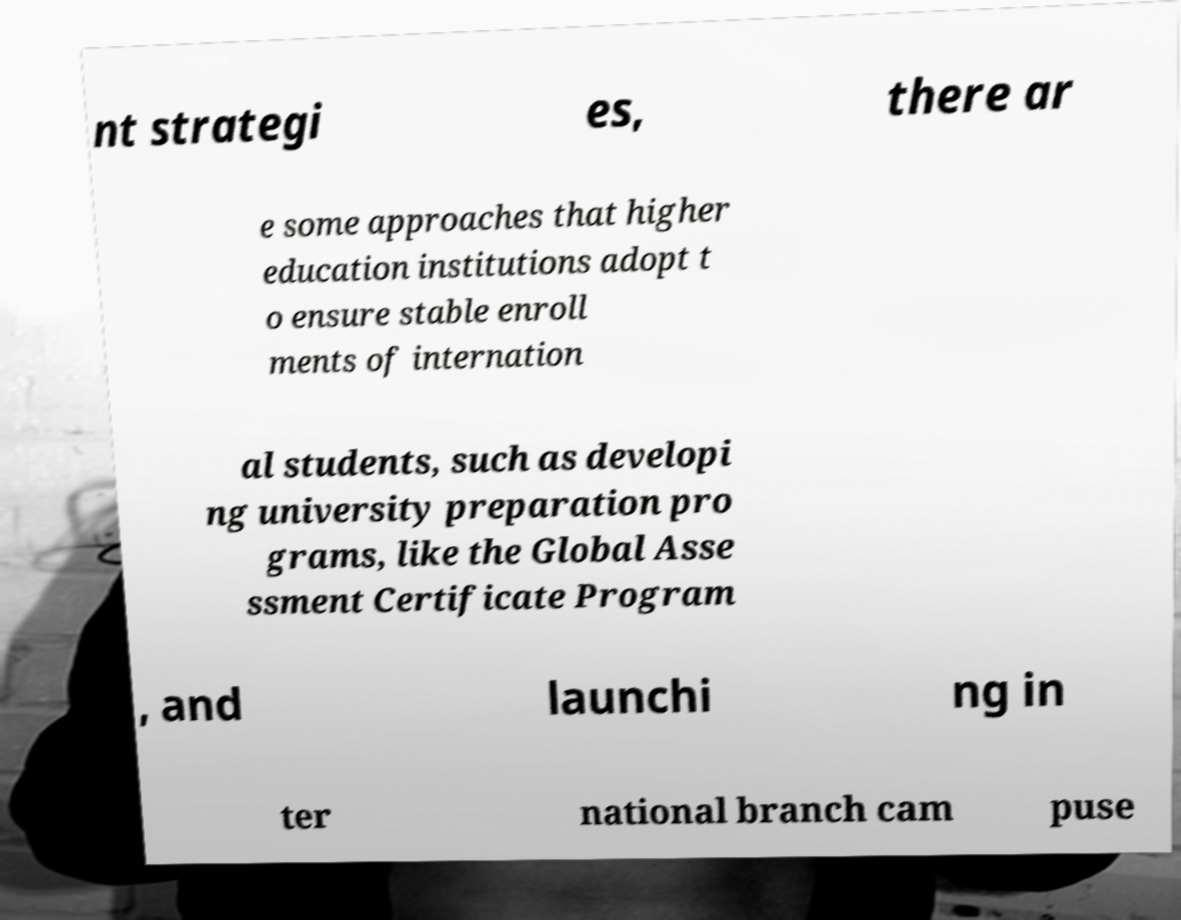Please read and relay the text visible in this image. What does it say? nt strategi es, there ar e some approaches that higher education institutions adopt t o ensure stable enroll ments of internation al students, such as developi ng university preparation pro grams, like the Global Asse ssment Certificate Program , and launchi ng in ter national branch cam puse 